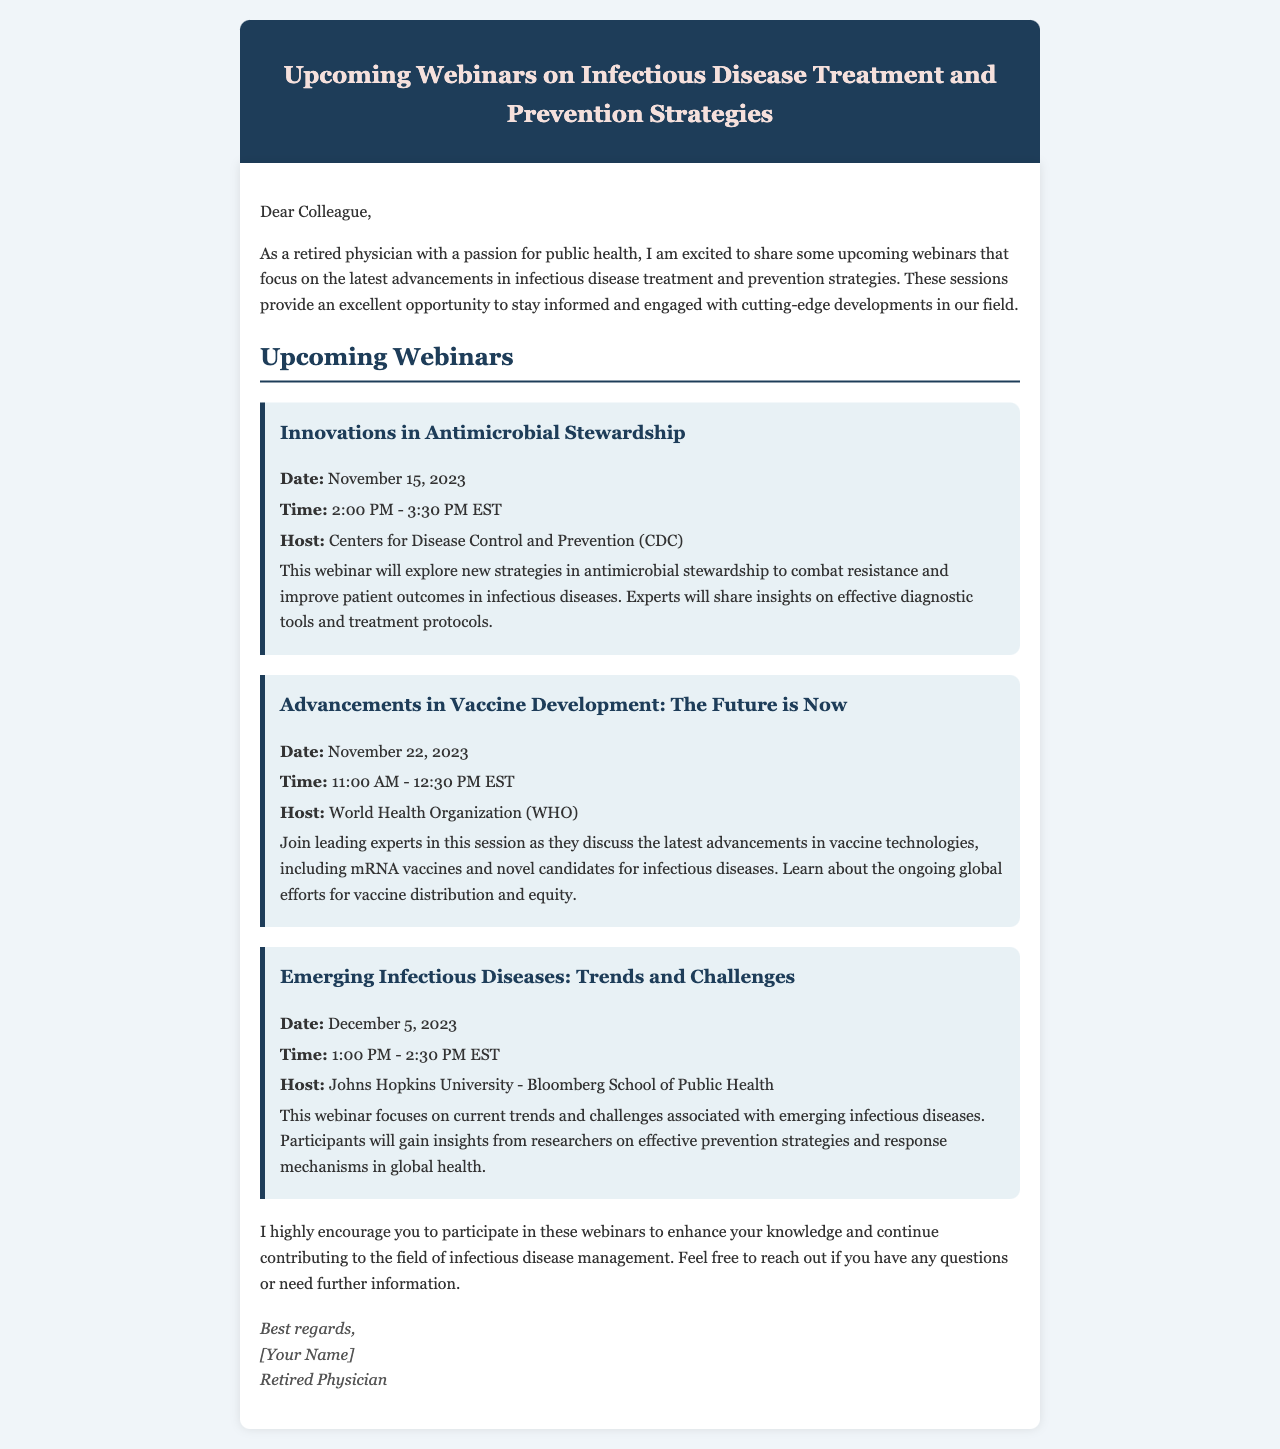what is the first webinar title? The first webinar title provided in the document is "Innovations in Antimicrobial Stewardship."
Answer: Innovations in Antimicrobial Stewardship what is the date of the second webinar? The date for the second webinar listed is November 22, 2023.
Answer: November 22, 2023 who is hosting the third webinar? The host of the third webinar is indicated as Johns Hopkins University - Bloomberg School of Public Health.
Answer: Johns Hopkins University - Bloomberg School of Public Health what is the time duration for the first webinar? The time duration for the first webinar is specified as 1.5 hours, from 2:00 PM to 3:30 PM EST.
Answer: 1.5 hours what is the focus of the second webinar? The focus of the second webinar is on advancements in vaccine technologies and distribution efforts.
Answer: Advancements in vaccine technologies what will participants gain insights into during the third webinar? Participants will gain insights from researchers on effective prevention strategies and response mechanisms.
Answer: Effective prevention strategies how many webinars are listed in this document? The document lists a total of three upcoming webinars.
Answer: Three what is the email's primary purpose? The primary purpose of the email is to inform about upcoming webinars focused on advancements in infectious disease treatment and prevention strategies.
Answer: Inform about upcoming webinars what is the closing salutation of the email? The closing salutation at the end of the email is "Best regards."
Answer: Best regards 